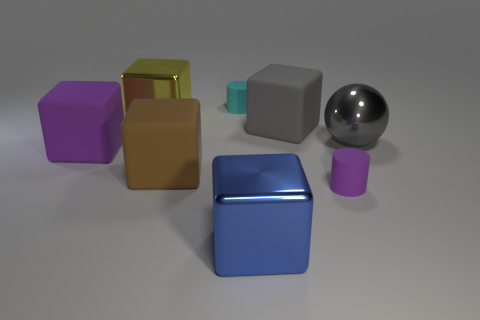What number of large objects are cyan metallic cylinders or gray metallic things?
Provide a short and direct response. 1. Are there the same number of tiny cyan matte things in front of the large yellow object and cyan cylinders?
Your answer should be very brief. No. There is a purple matte thing left of the blue cube; is there a yellow cube behind it?
Provide a short and direct response. Yes. What number of other objects are the same color as the big ball?
Provide a short and direct response. 1. The large ball has what color?
Give a very brief answer. Gray. There is a matte thing that is left of the blue cube and behind the big ball; how big is it?
Give a very brief answer. Small. How many things are large shiny blocks in front of the large sphere or tiny matte cylinders?
Make the answer very short. 3. There is a gray object that is the same material as the yellow cube; what shape is it?
Offer a very short reply. Sphere. What is the shape of the large yellow thing?
Keep it short and to the point. Cube. What color is the shiny object that is both to the left of the gray cube and in front of the big yellow cube?
Provide a short and direct response. Blue. 